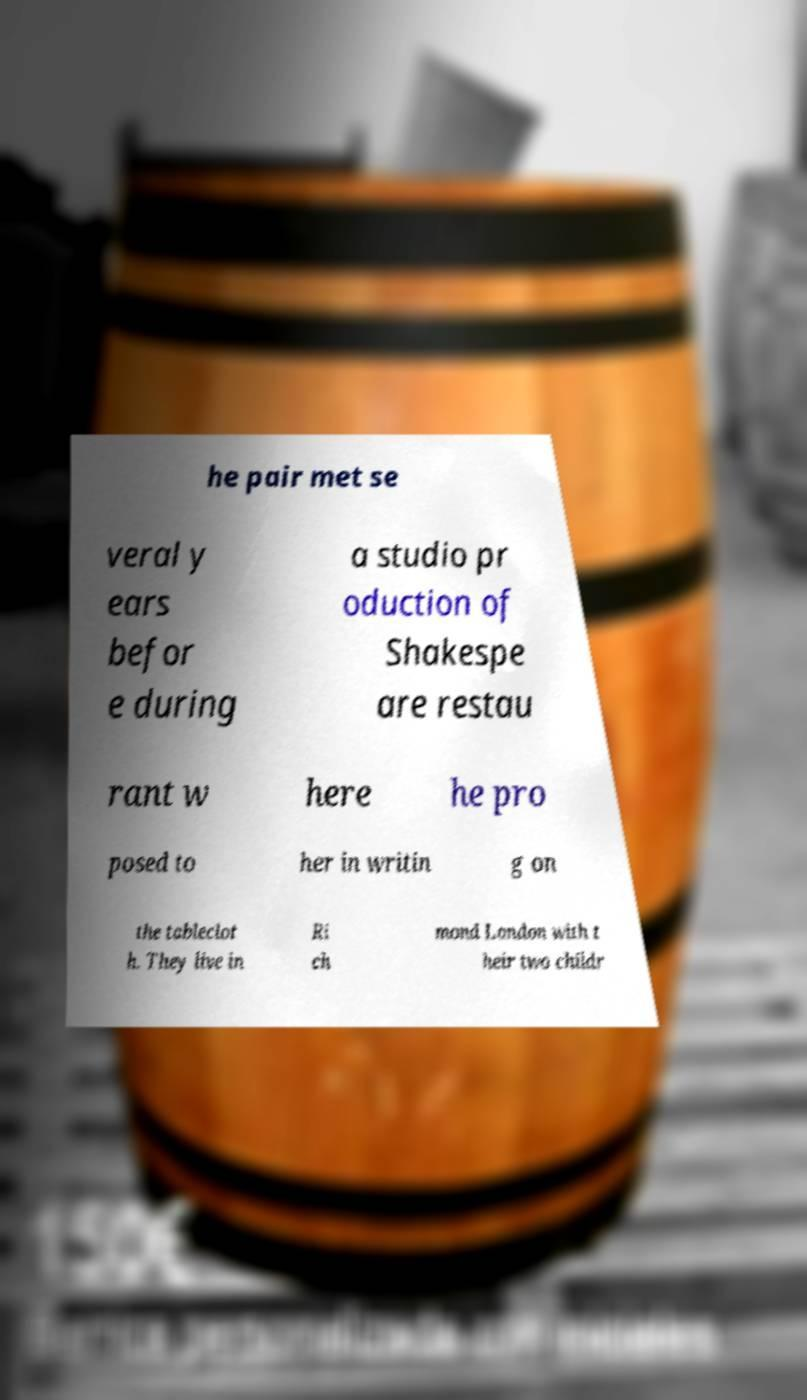I need the written content from this picture converted into text. Can you do that? he pair met se veral y ears befor e during a studio pr oduction of Shakespe are restau rant w here he pro posed to her in writin g on the tableclot h. They live in Ri ch mond London with t heir two childr 